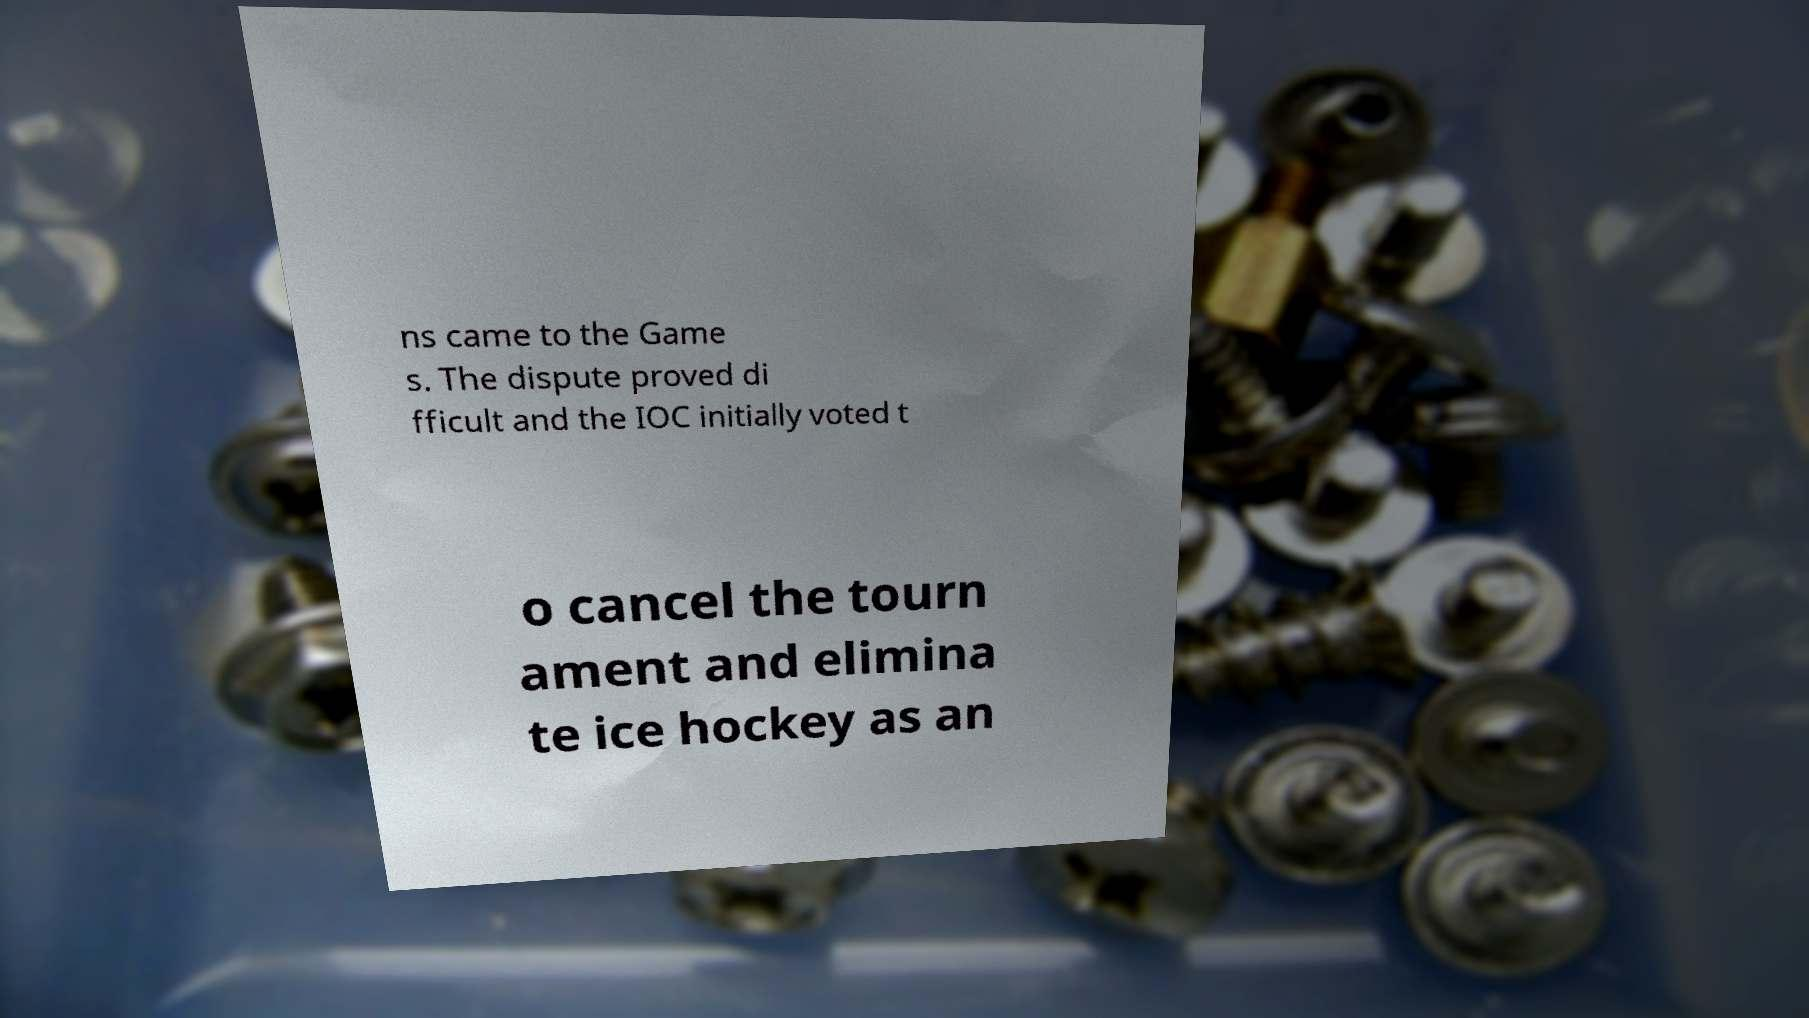What messages or text are displayed in this image? I need them in a readable, typed format. ns came to the Game s. The dispute proved di fficult and the IOC initially voted t o cancel the tourn ament and elimina te ice hockey as an 